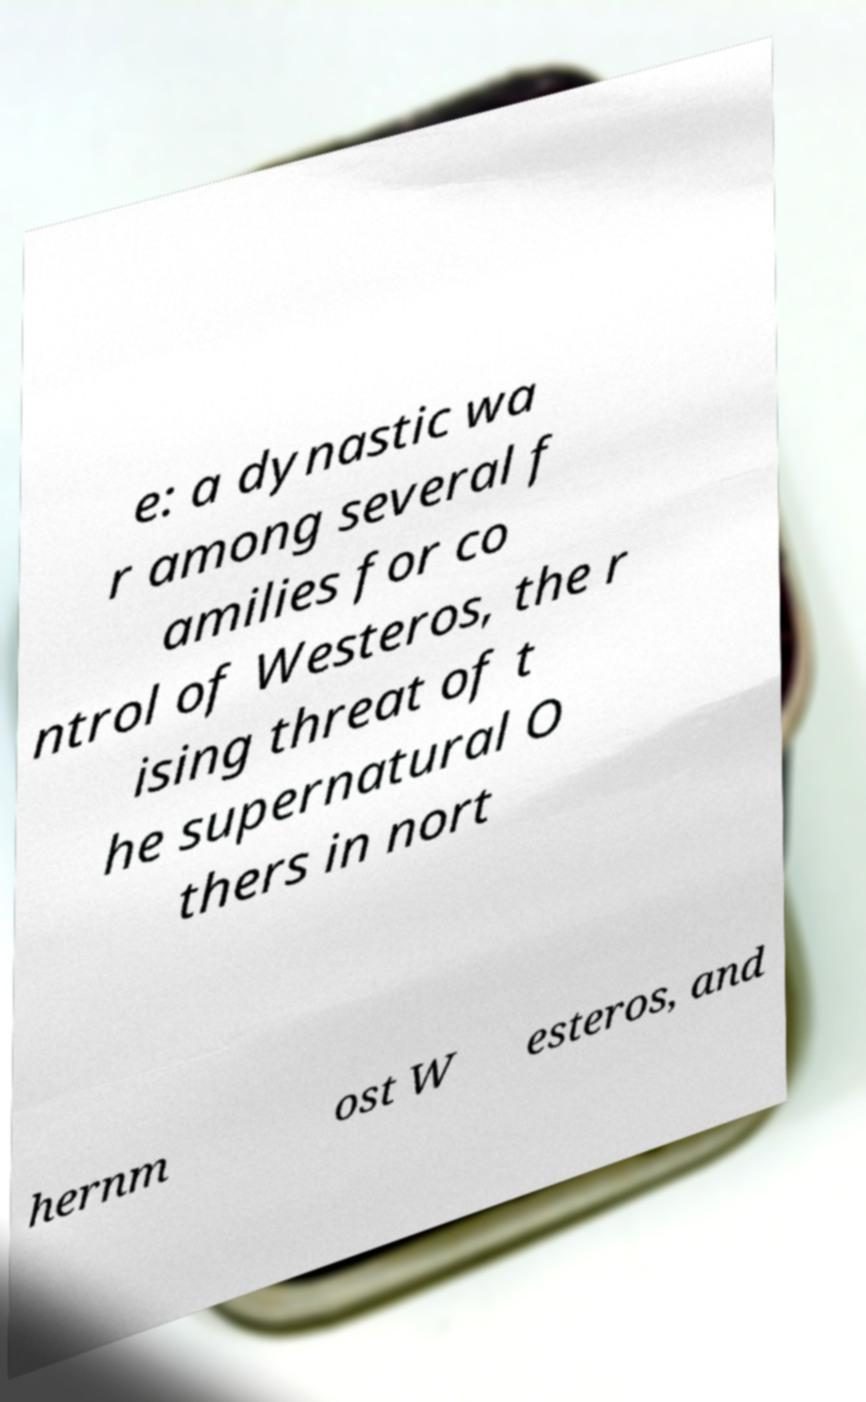Can you read and provide the text displayed in the image?This photo seems to have some interesting text. Can you extract and type it out for me? e: a dynastic wa r among several f amilies for co ntrol of Westeros, the r ising threat of t he supernatural O thers in nort hernm ost W esteros, and 